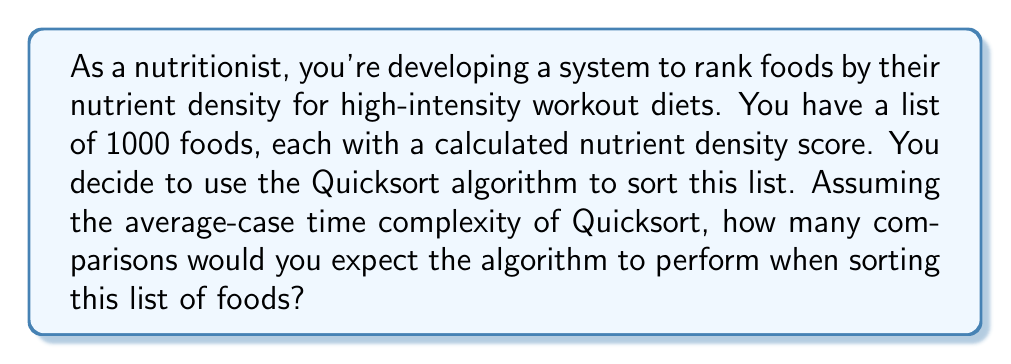Show me your answer to this math problem. To solve this problem, we need to consider the following steps:

1. Recall the average-case time complexity of Quicksort:
   The average-case time complexity of Quicksort is $O(n \log n)$, where $n$ is the number of elements to be sorted.

2. Understand what this complexity means in terms of comparisons:
   The $O(n \log n)$ complexity indicates that the number of comparisons is proportional to $n \log n$.

3. Calculate the exact number of comparisons:
   While the big O notation gives us the growth rate, for a more precise estimate, we can use the formula:

   $$C_{avg} = 2n \ln n - 1.386n$$

   Where $C_{avg}$ is the average number of comparisons, and $n$ is the number of elements.

4. Plug in the value for $n$:
   In this case, $n = 1000$ (the number of foods in the list).

   $$\begin{align*}
   C_{avg} &= 2(1000) \ln(1000) - 1.386(1000) \\
   &= 2000 \ln(1000) - 1386 \\
   &= 2000 \cdot 6.908 - 1386 \\
   &= 13816 - 1386 \\
   &= 12430
   \end{align*}$$

5. Round to the nearest whole number:
   Since we can't have a fractional number of comparisons, we round to the nearest integer.
Answer: 12430 comparisons 